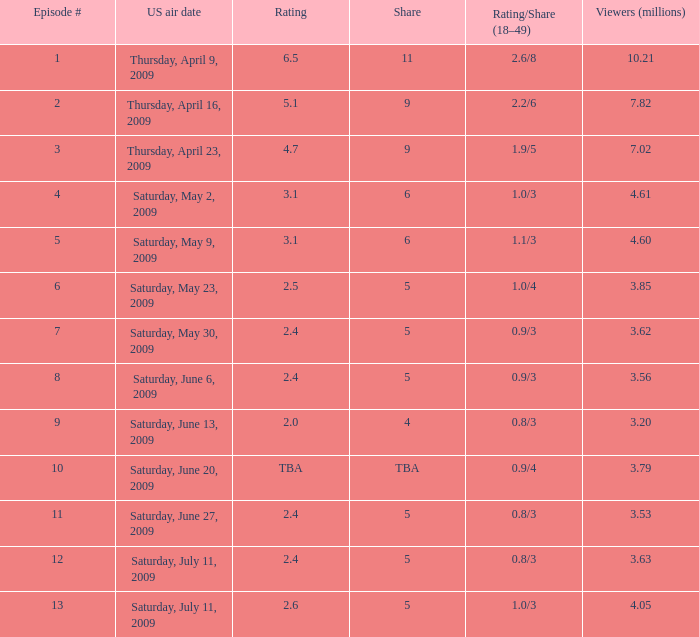What is the smallest number of million viewers for an episode prior to episode 5 that has a 1.1/3 rating/share? None. 